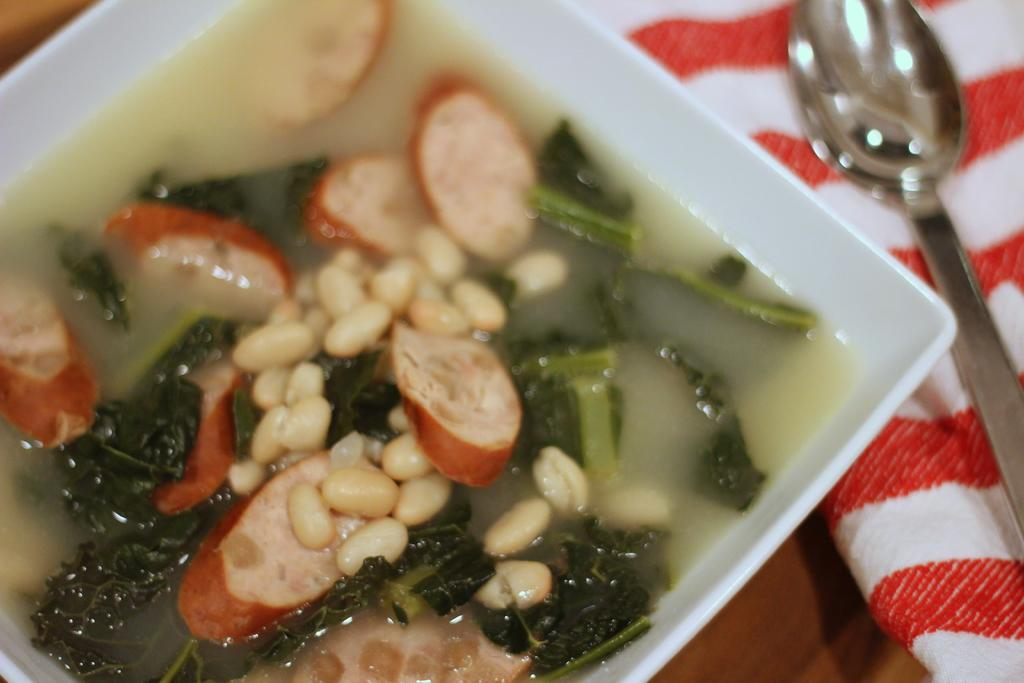What is in the bowl that is visible in the image? There is a bowl with food items in the image. What other items can be seen in the image? There is a cloth and a spoon visible in the image. Where are the bowl, cloth, and spoon located in the image? The bowl, cloth, and spoon are on a table in the image. Can you hear the sound of the waves at the seashore in the image? There is no reference to a seashore or any sounds in the image, so it's not possible to determine if waves can be heard. 